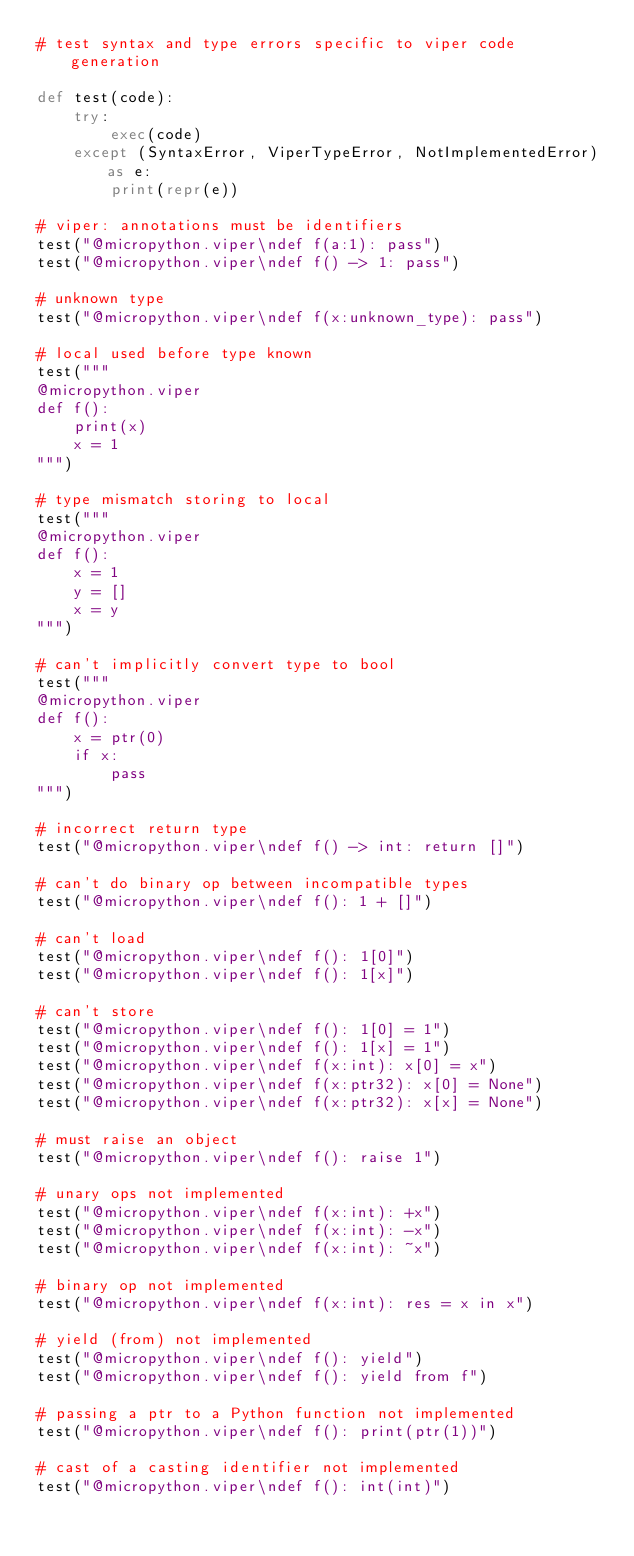Convert code to text. <code><loc_0><loc_0><loc_500><loc_500><_Python_># test syntax and type errors specific to viper code generation

def test(code):
    try:
        exec(code)
    except (SyntaxError, ViperTypeError, NotImplementedError) as e:
        print(repr(e))

# viper: annotations must be identifiers
test("@micropython.viper\ndef f(a:1): pass")
test("@micropython.viper\ndef f() -> 1: pass")

# unknown type
test("@micropython.viper\ndef f(x:unknown_type): pass")

# local used before type known
test("""
@micropython.viper
def f():
    print(x)
    x = 1
""")

# type mismatch storing to local
test("""
@micropython.viper
def f():
    x = 1
    y = []
    x = y
""")

# can't implicitly convert type to bool
test("""
@micropython.viper
def f():
    x = ptr(0)
    if x:
        pass
""")

# incorrect return type
test("@micropython.viper\ndef f() -> int: return []")

# can't do binary op between incompatible types
test("@micropython.viper\ndef f(): 1 + []")

# can't load
test("@micropython.viper\ndef f(): 1[0]")
test("@micropython.viper\ndef f(): 1[x]")

# can't store
test("@micropython.viper\ndef f(): 1[0] = 1")
test("@micropython.viper\ndef f(): 1[x] = 1")
test("@micropython.viper\ndef f(x:int): x[0] = x")
test("@micropython.viper\ndef f(x:ptr32): x[0] = None")
test("@micropython.viper\ndef f(x:ptr32): x[x] = None")

# must raise an object
test("@micropython.viper\ndef f(): raise 1")

# unary ops not implemented
test("@micropython.viper\ndef f(x:int): +x")
test("@micropython.viper\ndef f(x:int): -x")
test("@micropython.viper\ndef f(x:int): ~x")

# binary op not implemented
test("@micropython.viper\ndef f(x:int): res = x in x")

# yield (from) not implemented
test("@micropython.viper\ndef f(): yield")
test("@micropython.viper\ndef f(): yield from f")

# passing a ptr to a Python function not implemented
test("@micropython.viper\ndef f(): print(ptr(1))")

# cast of a casting identifier not implemented
test("@micropython.viper\ndef f(): int(int)")
</code> 